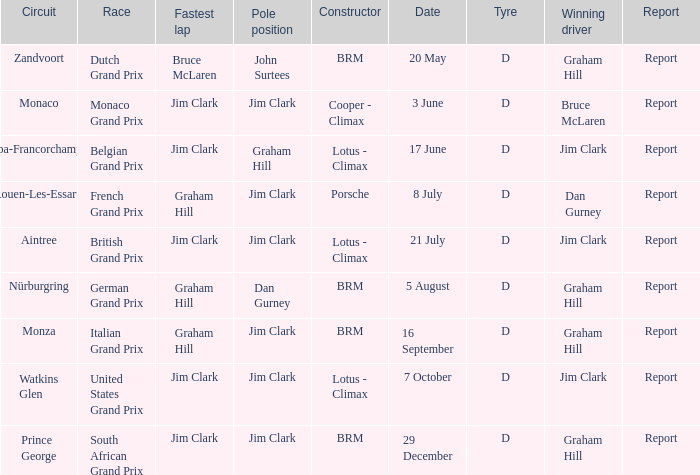What is the tyre for the circuit of Prince George, which had Jim Clark as the fastest lap? D. Would you be able to parse every entry in this table? {'header': ['Circuit', 'Race', 'Fastest lap', 'Pole position', 'Constructor', 'Date', 'Tyre', 'Winning driver', 'Report'], 'rows': [['Zandvoort', 'Dutch Grand Prix', 'Bruce McLaren', 'John Surtees', 'BRM', '20 May', 'D', 'Graham Hill', 'Report'], ['Monaco', 'Monaco Grand Prix', 'Jim Clark', 'Jim Clark', 'Cooper - Climax', '3 June', 'D', 'Bruce McLaren', 'Report'], ['Spa-Francorchamps', 'Belgian Grand Prix', 'Jim Clark', 'Graham Hill', 'Lotus - Climax', '17 June', 'D', 'Jim Clark', 'Report'], ['Rouen-Les-Essarts', 'French Grand Prix', 'Graham Hill', 'Jim Clark', 'Porsche', '8 July', 'D', 'Dan Gurney', 'Report'], ['Aintree', 'British Grand Prix', 'Jim Clark', 'Jim Clark', 'Lotus - Climax', '21 July', 'D', 'Jim Clark', 'Report'], ['Nürburgring', 'German Grand Prix', 'Graham Hill', 'Dan Gurney', 'BRM', '5 August', 'D', 'Graham Hill', 'Report'], ['Monza', 'Italian Grand Prix', 'Graham Hill', 'Jim Clark', 'BRM', '16 September', 'D', 'Graham Hill', 'Report'], ['Watkins Glen', 'United States Grand Prix', 'Jim Clark', 'Jim Clark', 'Lotus - Climax', '7 October', 'D', 'Jim Clark', 'Report'], ['Prince George', 'South African Grand Prix', 'Jim Clark', 'Jim Clark', 'BRM', '29 December', 'D', 'Graham Hill', 'Report']]} 